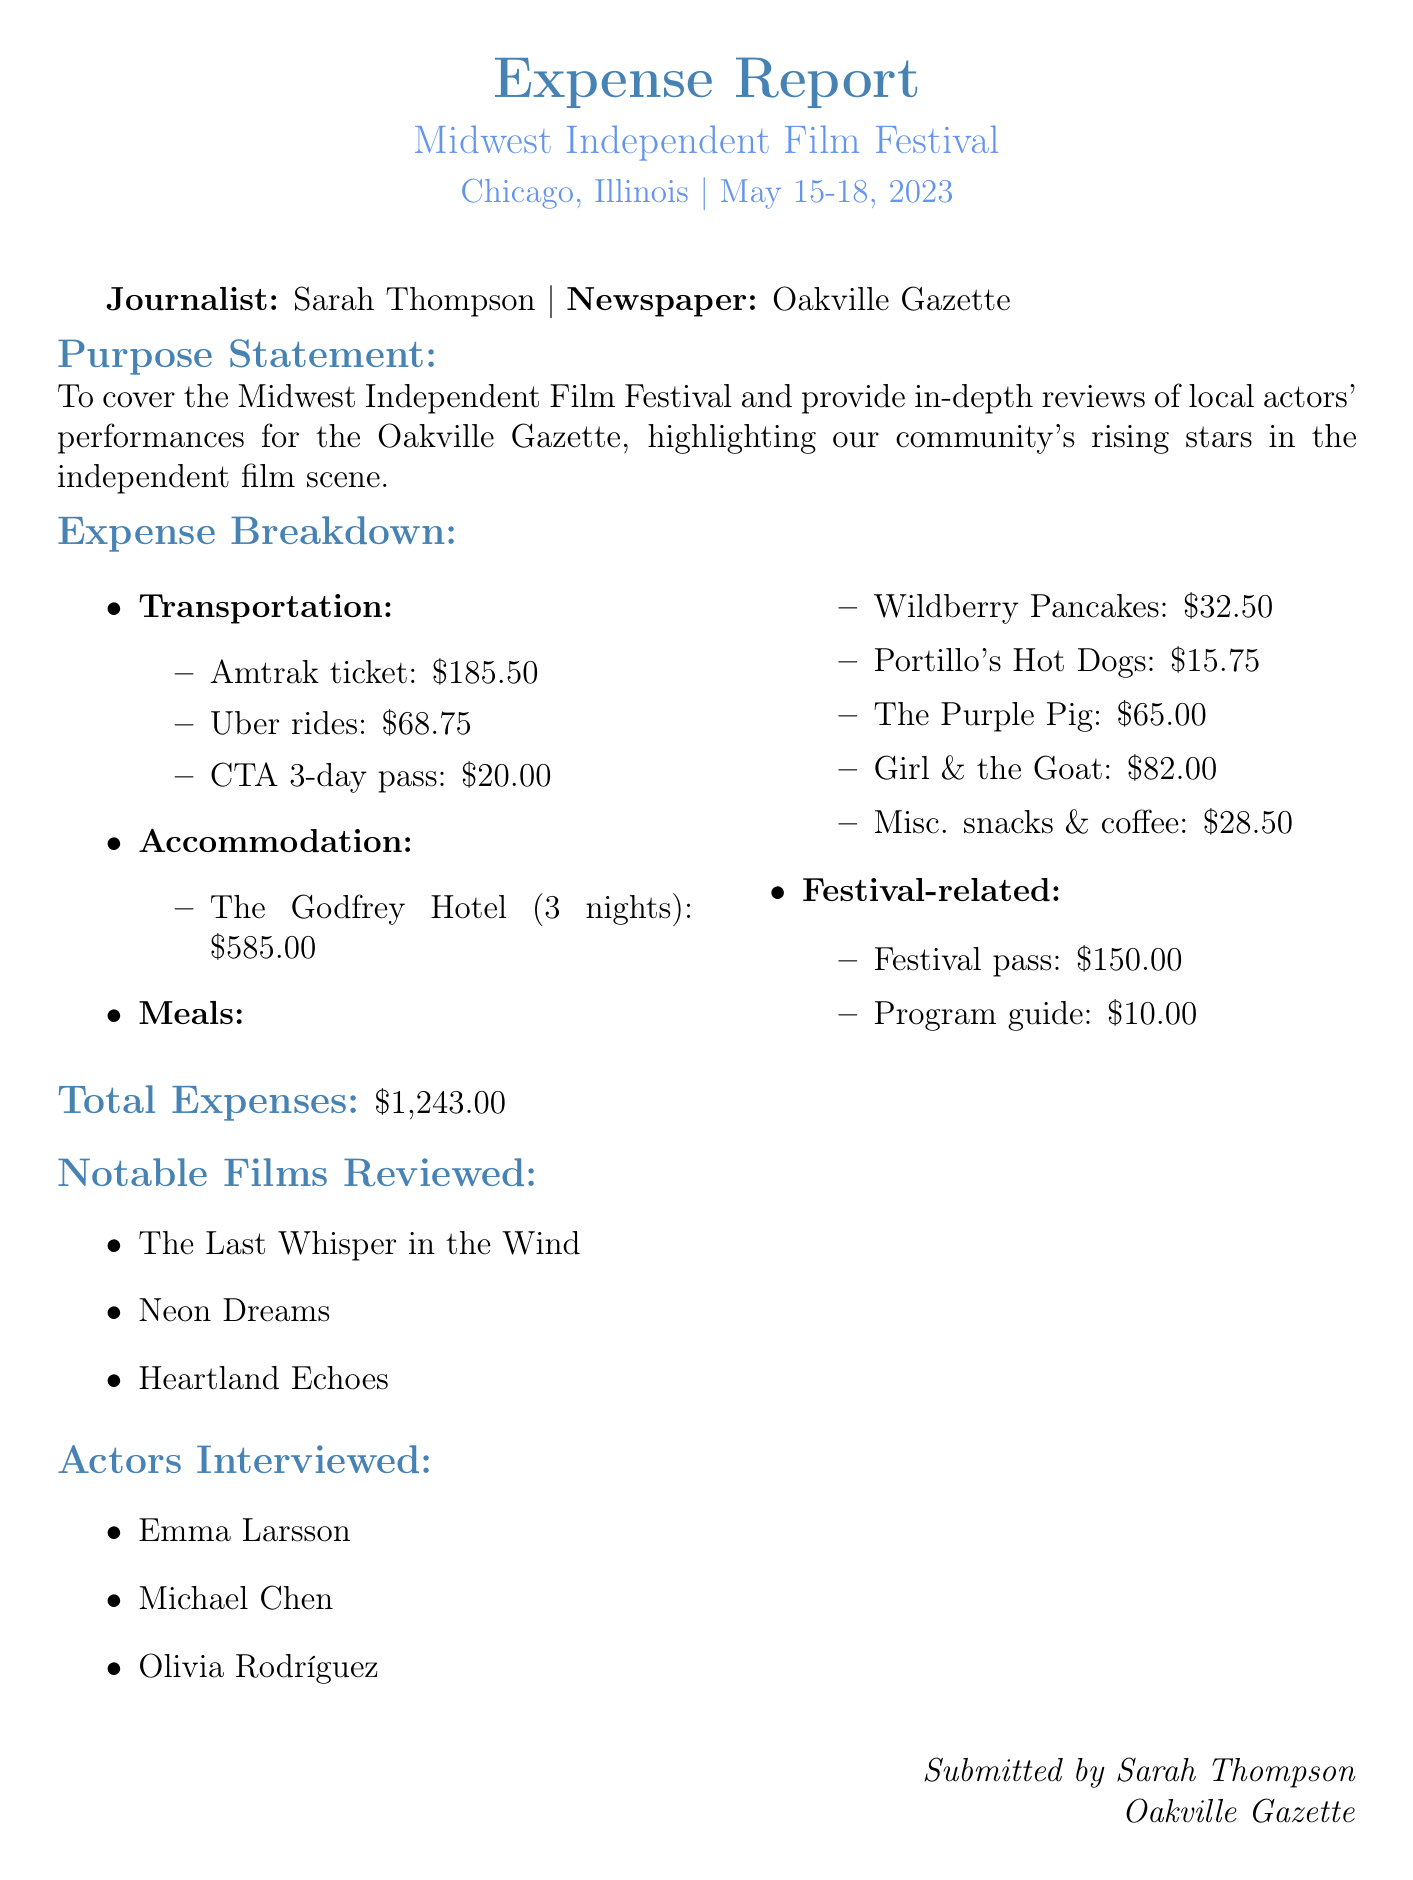What was the purpose of the trip? The purpose statement outlines the intent to cover the film festival and review local actors' performances.
Answer: To cover the Midwest Independent Film Festival and provide in-depth reviews of local actors' performances for the Oakville Gazette, highlighting our community's rising stars in the independent film scene What is the total amount of transportation expenses? By adding all individual transportation expenses (Amtrak ticket, Uber rides, and CTA pass), we find the total for this category.
Answer: $274.25 How many nights did Sarah stay at the hotel? The accommodation section specifies the duration of stay at The Godfrey Hotel.
Answer: 3 nights Which notable film was reviewed? The notable films listed provide three examples of films that were reviewed.
Answer: The Last Whisper in the Wind What was the cost of the festival pass? The expenses section lists the cost associated with the festival pass.
Answer: $150.00 Who were the actors interviewed? The section contains the names of the actors that were interviewed during the festival.
Answer: Emma Larsson, Michael Chen, Olivia Rodríguez What is the location of the Midwest Independent Film Festival? The document specifies the city and state where the event took place.
Answer: Chicago, Illinois What is the total expense amount? The total expenses are summarized at the end of the expense report.
Answer: $1,243.00 